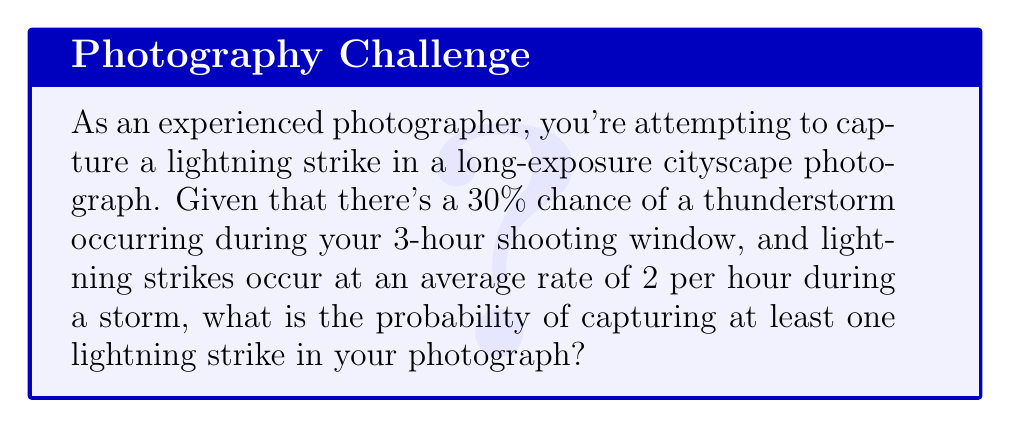Help me with this question. Let's approach this step-by-step:

1) First, we need to calculate the probability of a lightning strike occurring during the storm.
   - The rate is 2 strikes per hour
   - The shooting window is 3 hours
   - So, if a storm occurs, we expect $2 \times 3 = 6$ strikes

2) We can model the number of lightning strikes as a Poisson distribution with $\lambda = 6$.

3) The probability of capturing at least one strike is the complement of capturing no strikes:

   $P(\text{at least one strike}) = 1 - P(\text{no strikes})$

4) In a Poisson distribution, the probability of exactly $k$ events is given by:

   $P(X = k) = \frac{e^{-\lambda}\lambda^k}{k!}$

5) For no strikes $(k = 0)$:

   $P(X = 0) = \frac{e^{-6}6^0}{0!} = e^{-6} \approx 0.0025$

6) So, if a storm occurs, the probability of capturing at least one strike is:

   $1 - 0.0025 = 0.9975$

7) However, there's only a 30% chance of a storm occurring. We need to account for this:

   $P(\text{at least one strike}) = P(\text{storm}) \times P(\text{at least one strike | storm})$
   
   $= 0.30 \times 0.9975 = 0.29925$

Therefore, the probability of capturing at least one lightning strike is approximately 0.29925 or 29.925%.
Answer: $0.29925$ or $29.925\%$ 